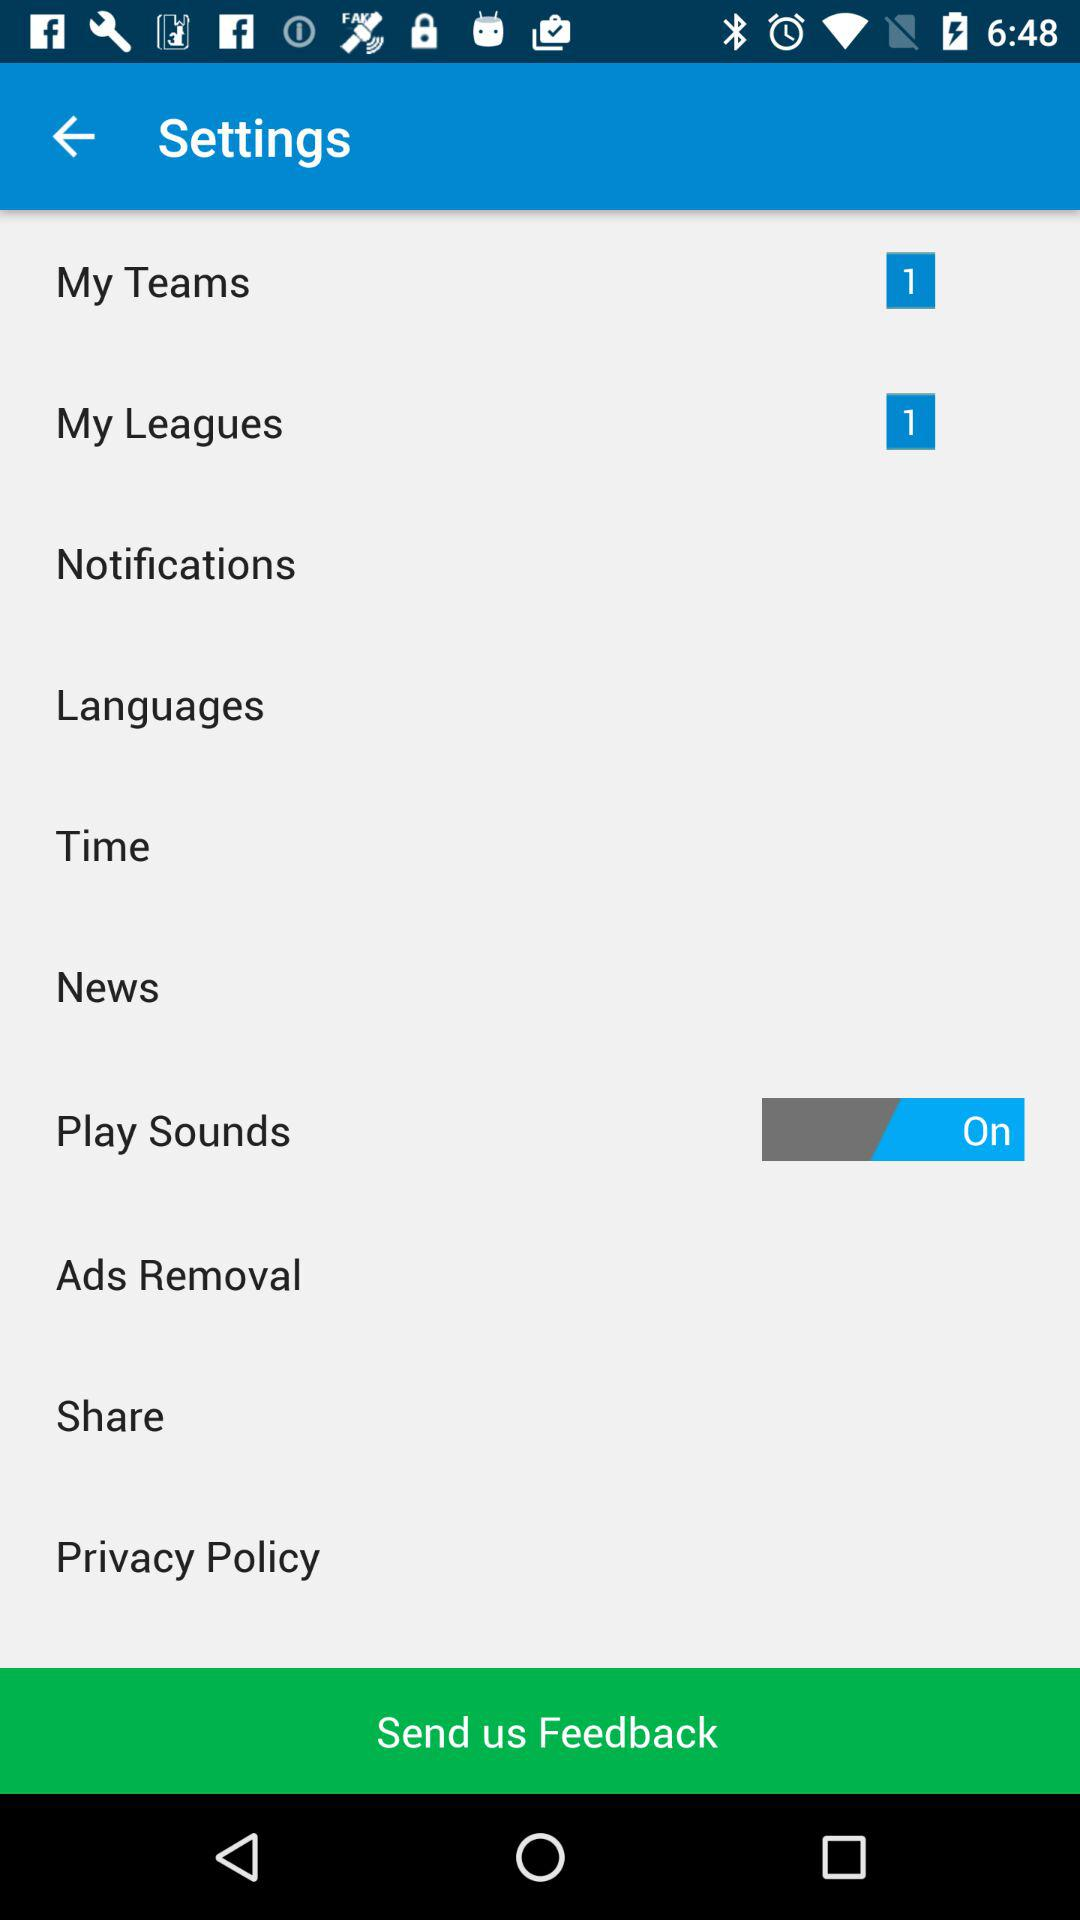What's the number of notifications in "My Leagues"? The number of notifications in "My Leagues" is 1. 